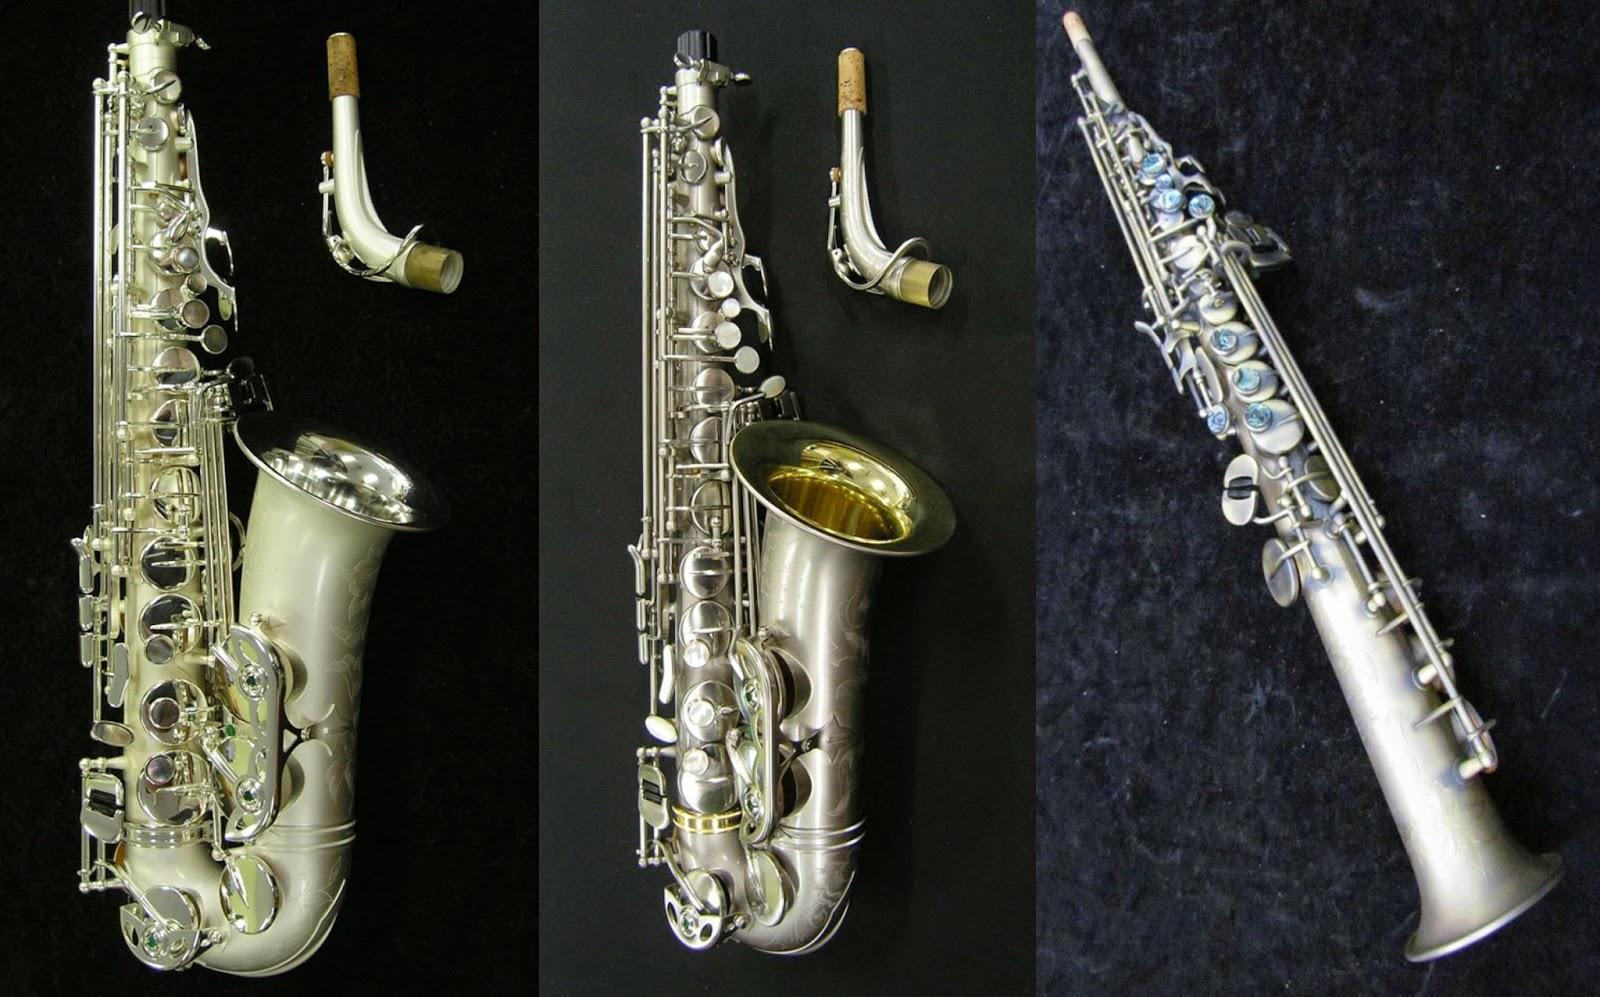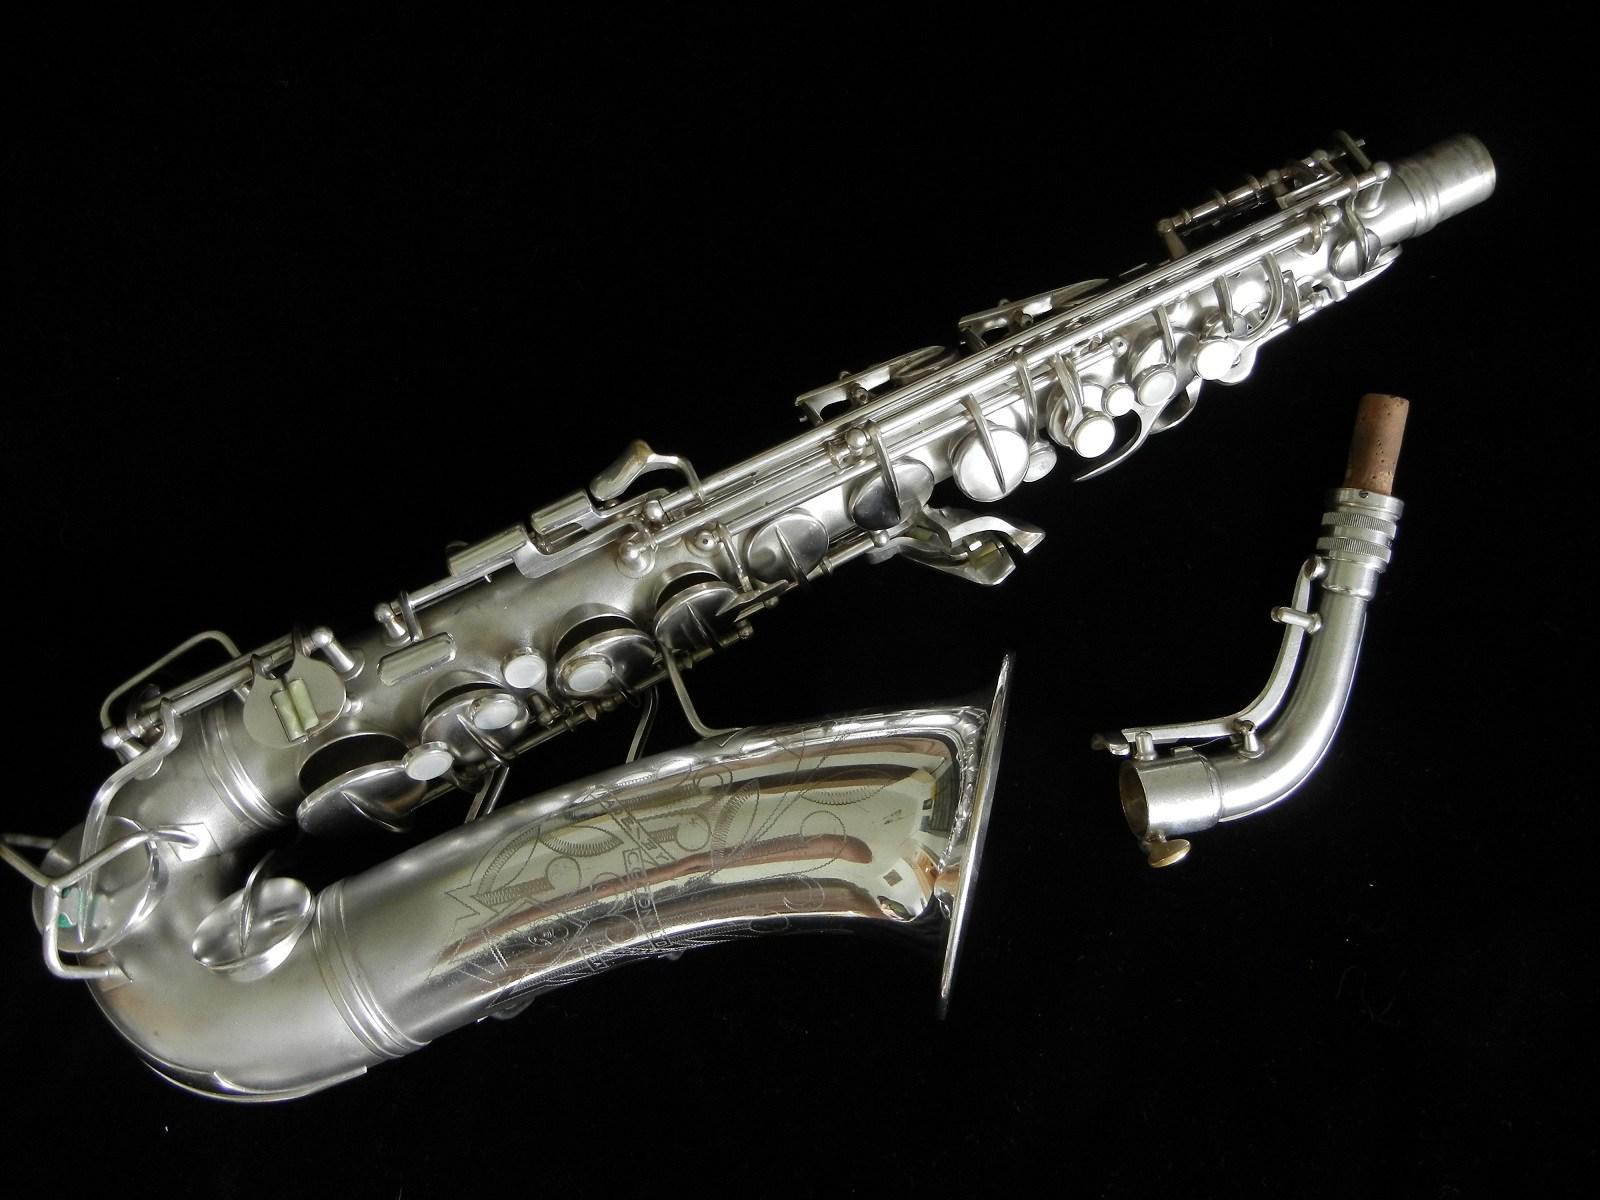The first image is the image on the left, the second image is the image on the right. For the images shown, is this caption "A total of at least three mouthpieces are shown separate from a saxophone." true? Answer yes or no. Yes. 